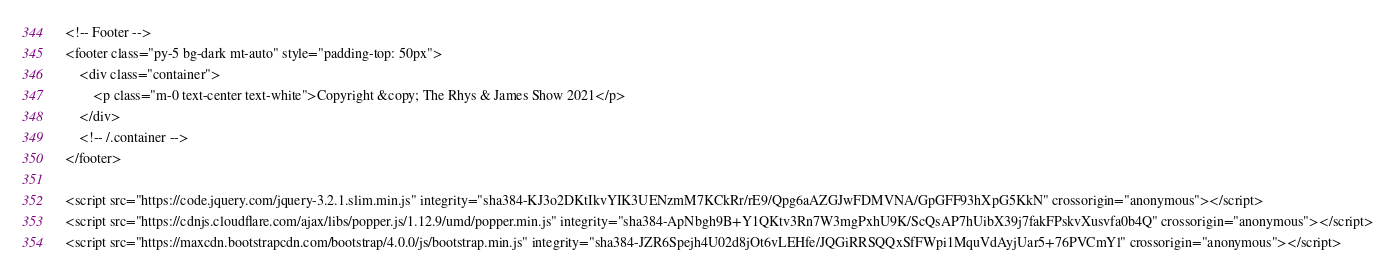<code> <loc_0><loc_0><loc_500><loc_500><_PHP_><!-- Footer -->
<footer class="py-5 bg-dark mt-auto" style="padding-top: 50px">
    <div class="container">
        <p class="m-0 text-center text-white">Copyright &copy; The Rhys & James Show 2021</p>
    </div>
    <!-- /.container -->
</footer>

<script src="https://code.jquery.com/jquery-3.2.1.slim.min.js" integrity="sha384-KJ3o2DKtIkvYIK3UENzmM7KCkRr/rE9/Qpg6aAZGJwFDMVNA/GpGFF93hXpG5KkN" crossorigin="anonymous"></script>
<script src="https://cdnjs.cloudflare.com/ajax/libs/popper.js/1.12.9/umd/popper.min.js" integrity="sha384-ApNbgh9B+Y1QKtv3Rn7W3mgPxhU9K/ScQsAP7hUibX39j7fakFPskvXusvfa0b4Q" crossorigin="anonymous"></script>
<script src="https://maxcdn.bootstrapcdn.com/bootstrap/4.0.0/js/bootstrap.min.js" integrity="sha384-JZR6Spejh4U02d8jOt6vLEHfe/JQGiRRSQQxSfFWpi1MquVdAyjUar5+76PVCmYl" crossorigin="anonymous"></script>
</code> 